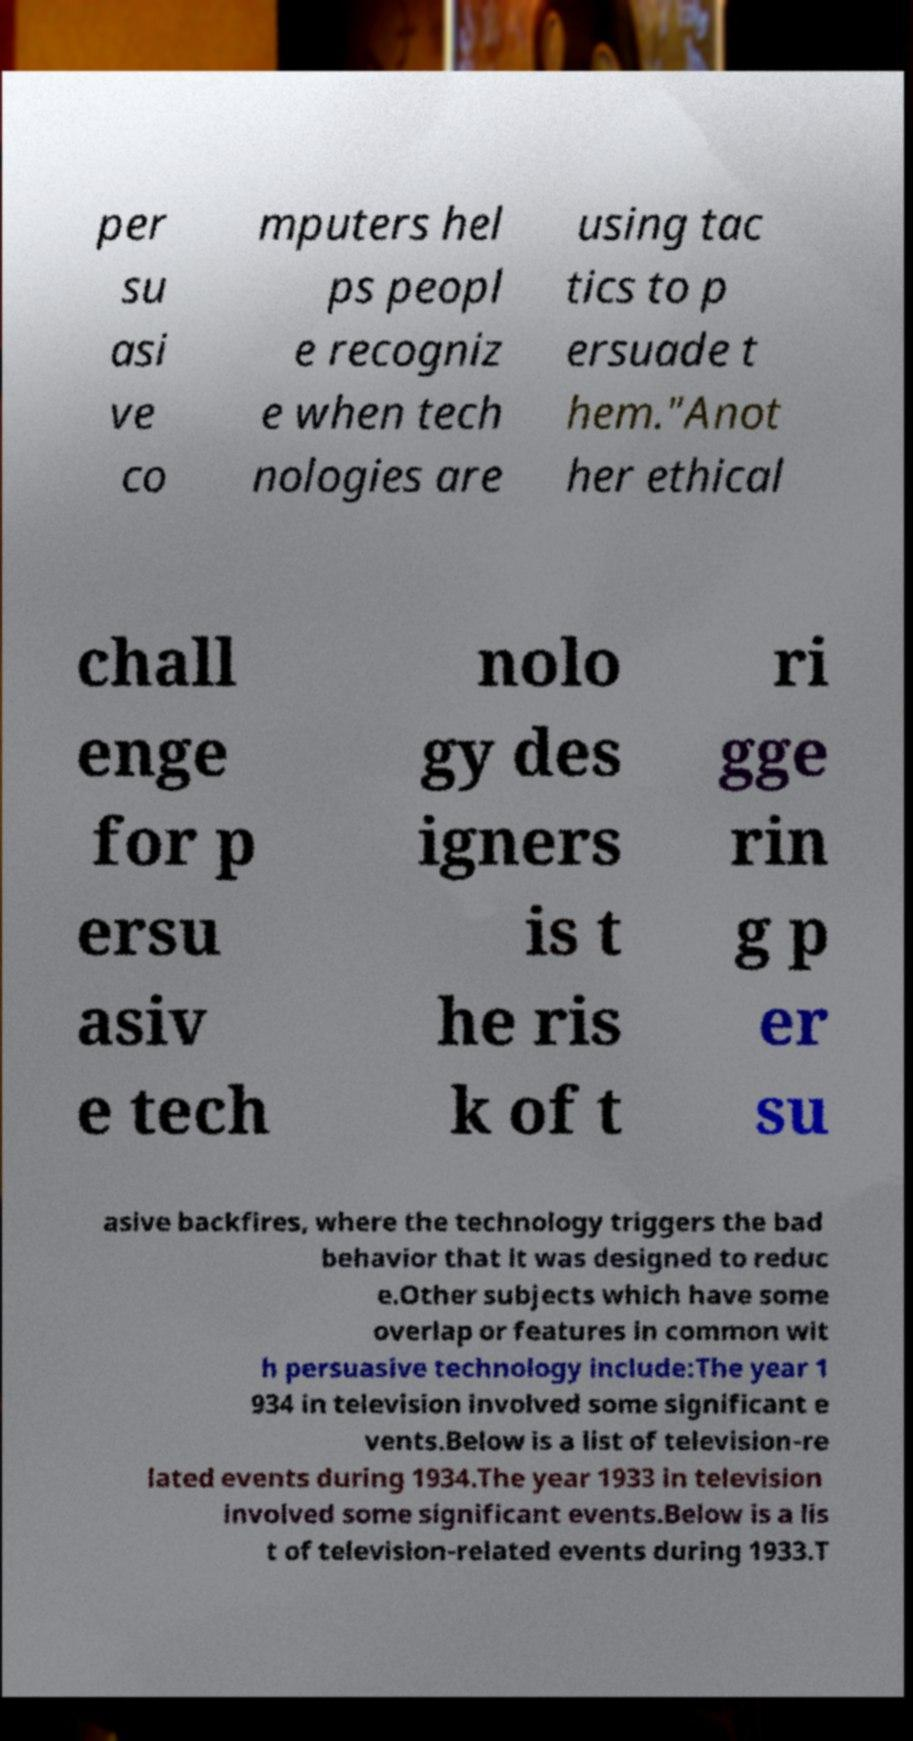Can you read and provide the text displayed in the image?This photo seems to have some interesting text. Can you extract and type it out for me? per su asi ve co mputers hel ps peopl e recogniz e when tech nologies are using tac tics to p ersuade t hem."Anot her ethical chall enge for p ersu asiv e tech nolo gy des igners is t he ris k of t ri gge rin g p er su asive backfires, where the technology triggers the bad behavior that it was designed to reduc e.Other subjects which have some overlap or features in common wit h persuasive technology include:The year 1 934 in television involved some significant e vents.Below is a list of television-re lated events during 1934.The year 1933 in television involved some significant events.Below is a lis t of television-related events during 1933.T 